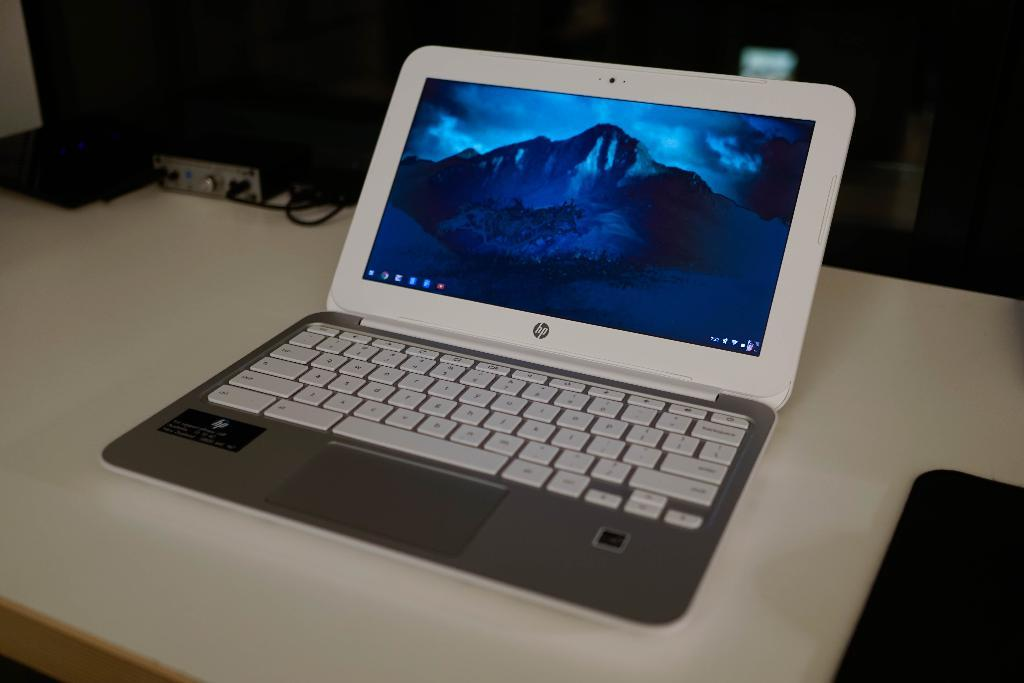<image>
Describe the image concisely. An opened HP  laptop computer shows keyboard and display 